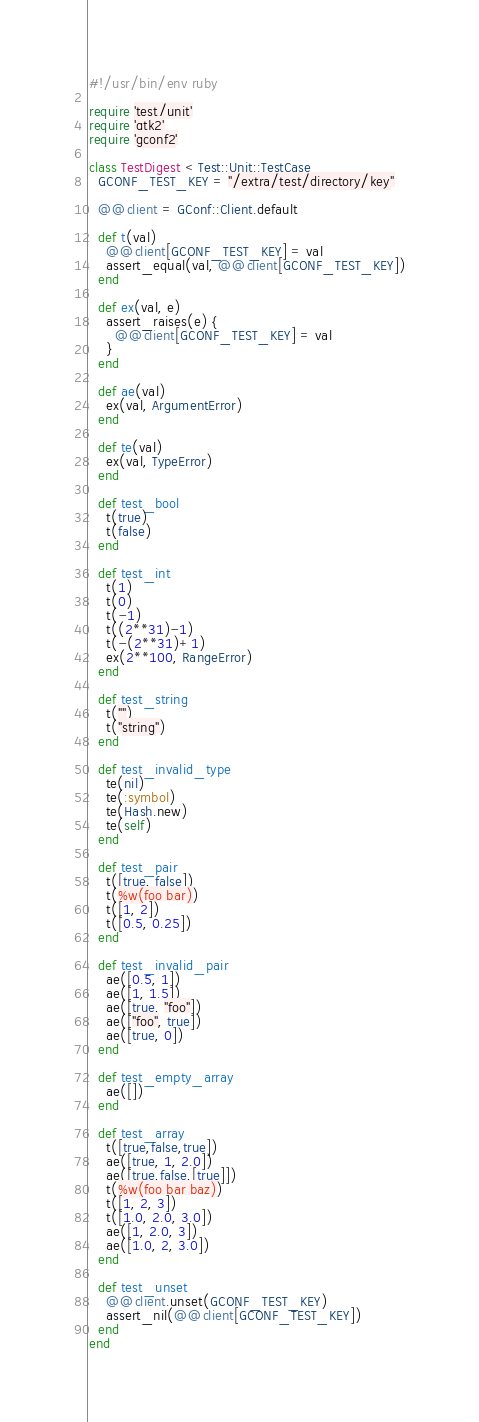Convert code to text. <code><loc_0><loc_0><loc_500><loc_500><_Ruby_>#!/usr/bin/env ruby

require 'test/unit'
require 'gtk2'
require 'gconf2'

class TestDigest < Test::Unit::TestCase
  GCONF_TEST_KEY = "/extra/test/directory/key"

  @@client = GConf::Client.default

  def t(val)
    @@client[GCONF_TEST_KEY] = val
    assert_equal(val, @@client[GCONF_TEST_KEY])
  end

  def ex(val, e)
    assert_raises(e) {
      @@client[GCONF_TEST_KEY] = val
    }
  end

  def ae(val)
    ex(val, ArgumentError)
  end

  def te(val)
    ex(val, TypeError)
  end

  def test_bool
    t(true)
    t(false)
  end

  def test_int
    t(1)
    t(0)
    t(-1)
    t((2**31)-1)
    t(-(2**31)+1)
    ex(2**100, RangeError)
  end

  def test_string
    t("")
    t("string")
  end

  def test_invalid_type
    te(nil)
    te(:symbol)
    te(Hash.new)
    te(self)
  end

  def test_pair
    t([true, false])
    t(%w(foo bar))
    t([1, 2])
    t([0.5, 0.25])
  end

  def test_invalid_pair
    ae([0.5, 1])
    ae([1, 1.5])
    ae([true, "foo"])
    ae(["foo", true])
    ae([true, 0])
  end

  def test_empty_array
    ae([])
  end

  def test_array
    t([true,false,true])
    ae([true, 1, 2.0])
    ae([true,false,[true]])
    t(%w(foo bar baz))
    t([1, 2, 3])
    t([1.0, 2.0, 3.0])
    ae([1, 2.0, 3])
    ae([1.0, 2, 3.0])
  end

  def test_unset
    @@client.unset(GCONF_TEST_KEY)
    assert_nil(@@client[GCONF_TEST_KEY])
  end
end
</code> 